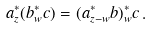<formula> <loc_0><loc_0><loc_500><loc_500>a ^ { * } _ { z } ( b ^ { * } _ { w } c ) = ( a ^ { * } _ { z - w } b ) ^ { * } _ { w } c \, .</formula> 